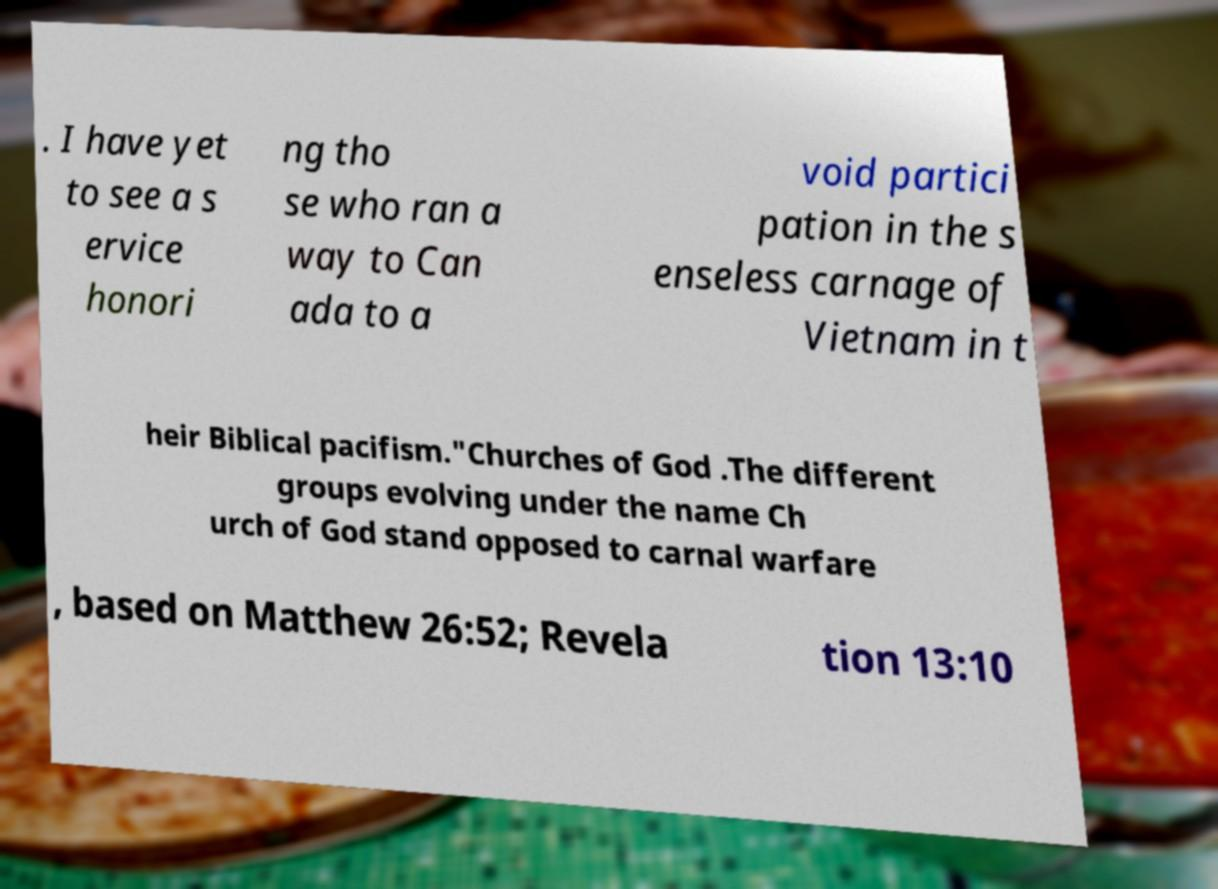Can you read and provide the text displayed in the image?This photo seems to have some interesting text. Can you extract and type it out for me? . I have yet to see a s ervice honori ng tho se who ran a way to Can ada to a void partici pation in the s enseless carnage of Vietnam in t heir Biblical pacifism."Churches of God .The different groups evolving under the name Ch urch of God stand opposed to carnal warfare , based on Matthew 26:52; Revela tion 13:10 